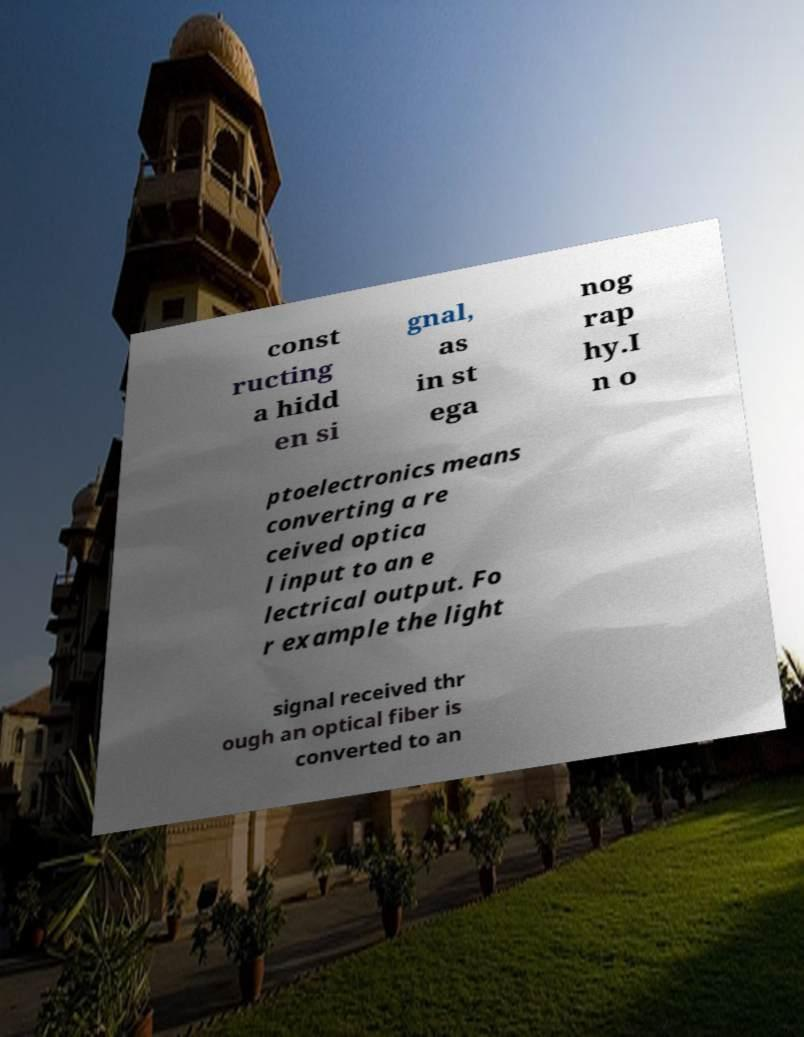Can you read and provide the text displayed in the image?This photo seems to have some interesting text. Can you extract and type it out for me? const ructing a hidd en si gnal, as in st ega nog rap hy.I n o ptoelectronics means converting a re ceived optica l input to an e lectrical output. Fo r example the light signal received thr ough an optical fiber is converted to an 